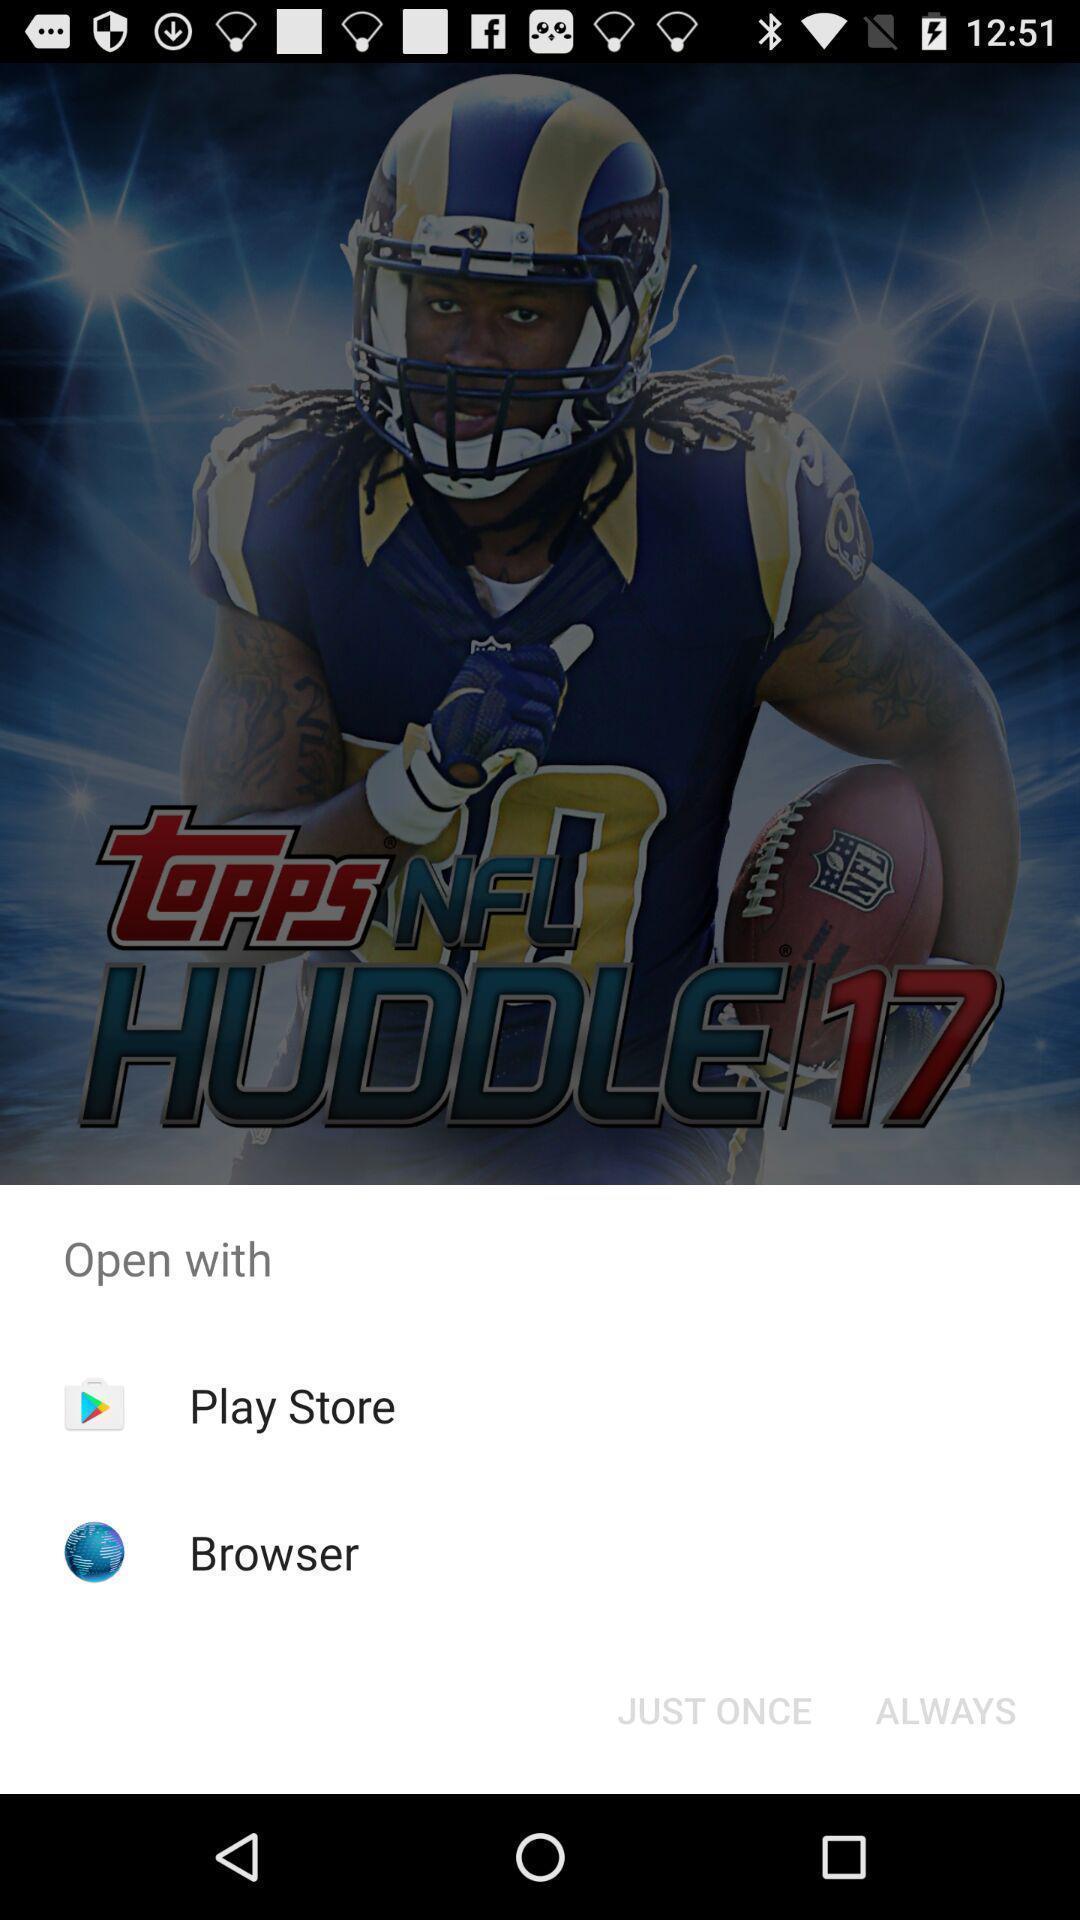Describe the content in this image. Pop-up to open an application with multiple options. 